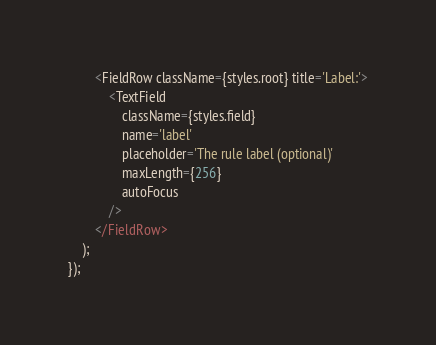<code> <loc_0><loc_0><loc_500><loc_500><_TypeScript_>		<FieldRow className={styles.root} title='Label:'>
			<TextField
				className={styles.field}
				name='label'
				placeholder='The rule label (optional)'
				maxLength={256}
				autoFocus
			/>
		</FieldRow>
	);
});
</code> 